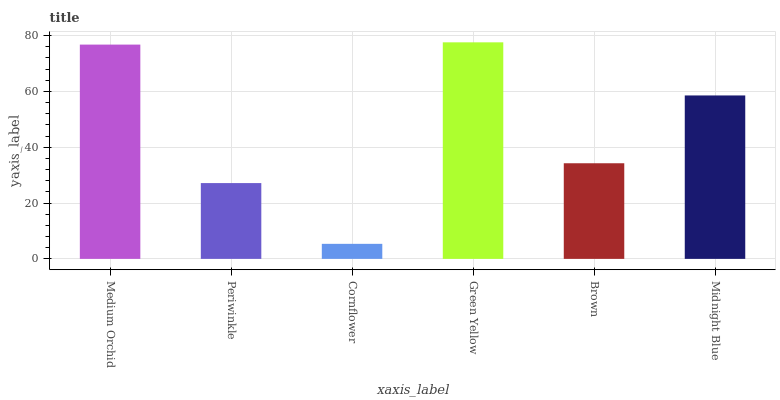Is Cornflower the minimum?
Answer yes or no. Yes. Is Green Yellow the maximum?
Answer yes or no. Yes. Is Periwinkle the minimum?
Answer yes or no. No. Is Periwinkle the maximum?
Answer yes or no. No. Is Medium Orchid greater than Periwinkle?
Answer yes or no. Yes. Is Periwinkle less than Medium Orchid?
Answer yes or no. Yes. Is Periwinkle greater than Medium Orchid?
Answer yes or no. No. Is Medium Orchid less than Periwinkle?
Answer yes or no. No. Is Midnight Blue the high median?
Answer yes or no. Yes. Is Brown the low median?
Answer yes or no. Yes. Is Cornflower the high median?
Answer yes or no. No. Is Periwinkle the low median?
Answer yes or no. No. 